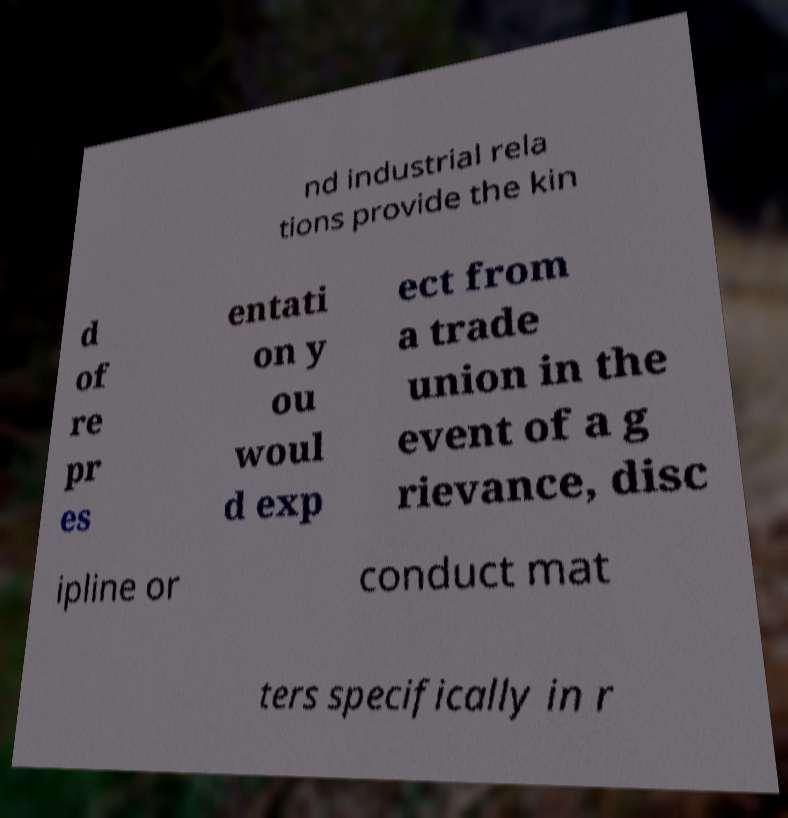There's text embedded in this image that I need extracted. Can you transcribe it verbatim? nd industrial rela tions provide the kin d of re pr es entati on y ou woul d exp ect from a trade union in the event of a g rievance, disc ipline or conduct mat ters specifically in r 